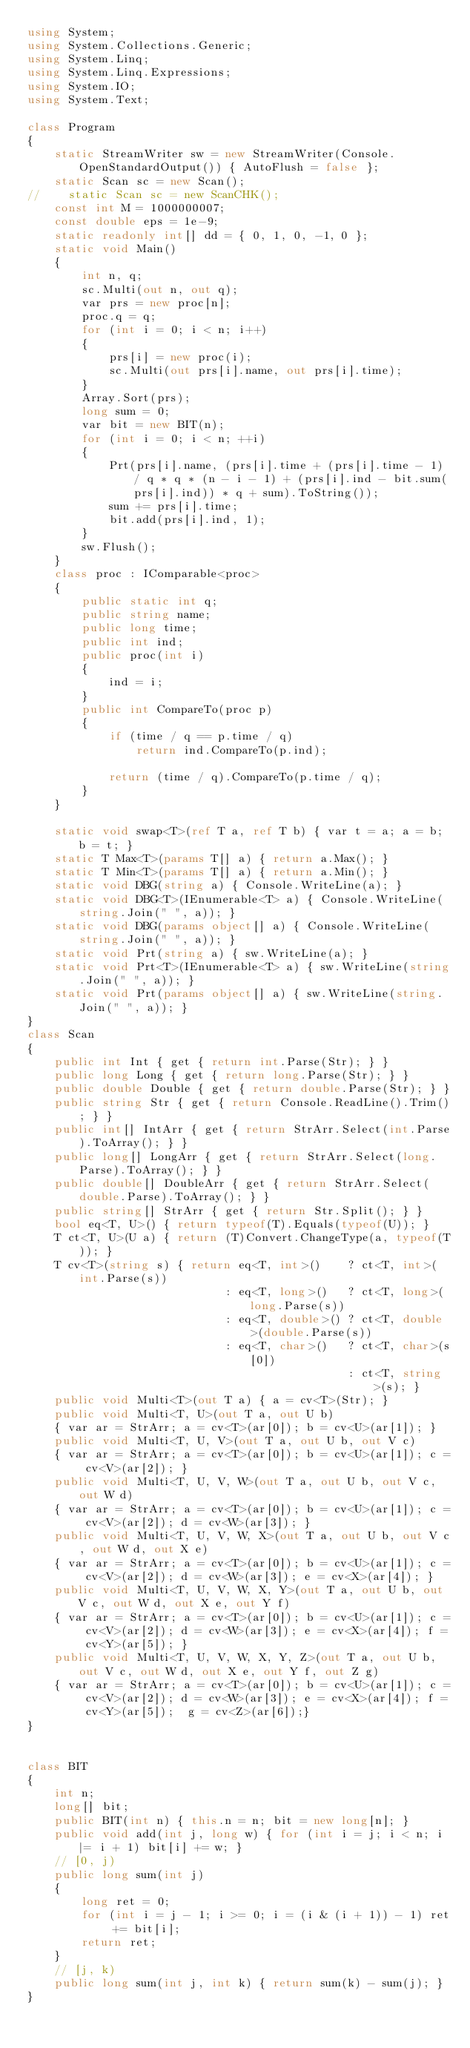Convert code to text. <code><loc_0><loc_0><loc_500><loc_500><_C#_>using System;
using System.Collections.Generic;
using System.Linq;
using System.Linq.Expressions;
using System.IO;
using System.Text;

class Program
{
    static StreamWriter sw = new StreamWriter(Console.OpenStandardOutput()) { AutoFlush = false };
    static Scan sc = new Scan();
//    static Scan sc = new ScanCHK();
    const int M = 1000000007;
    const double eps = 1e-9;
    static readonly int[] dd = { 0, 1, 0, -1, 0 };
    static void Main()
    {
        int n, q;
        sc.Multi(out n, out q);
        var prs = new proc[n];
        proc.q = q;
        for (int i = 0; i < n; i++)
        {
            prs[i] = new proc(i);
            sc.Multi(out prs[i].name, out prs[i].time);
        }
        Array.Sort(prs);
        long sum = 0;
        var bit = new BIT(n);
        for (int i = 0; i < n; ++i)
        {
            Prt(prs[i].name, (prs[i].time + (prs[i].time - 1) / q * q * (n - i - 1) + (prs[i].ind - bit.sum(prs[i].ind)) * q + sum).ToString());
            sum += prs[i].time;
            bit.add(prs[i].ind, 1);
        }
        sw.Flush();
    }
    class proc : IComparable<proc>
    {
        public static int q;
        public string name;
        public long time;
        public int ind;
        public proc(int i)
        {
            ind = i;
        }
        public int CompareTo(proc p)
        {
            if (time / q == p.time / q)
                return ind.CompareTo(p.ind);

            return (time / q).CompareTo(p.time / q);
        }
    }

    static void swap<T>(ref T a, ref T b) { var t = a; a = b; b = t; }
    static T Max<T>(params T[] a) { return a.Max(); }
    static T Min<T>(params T[] a) { return a.Min(); }
    static void DBG(string a) { Console.WriteLine(a); }
    static void DBG<T>(IEnumerable<T> a) { Console.WriteLine(string.Join(" ", a)); }
    static void DBG(params object[] a) { Console.WriteLine(string.Join(" ", a)); }
    static void Prt(string a) { sw.WriteLine(a); }
    static void Prt<T>(IEnumerable<T> a) { sw.WriteLine(string.Join(" ", a)); }
    static void Prt(params object[] a) { sw.WriteLine(string.Join(" ", a)); }
}
class Scan
{
    public int Int { get { return int.Parse(Str); } }
    public long Long { get { return long.Parse(Str); } }
    public double Double { get { return double.Parse(Str); } }
    public string Str { get { return Console.ReadLine().Trim(); } }
    public int[] IntArr { get { return StrArr.Select(int.Parse).ToArray(); } }
    public long[] LongArr { get { return StrArr.Select(long.Parse).ToArray(); } }
    public double[] DoubleArr { get { return StrArr.Select(double.Parse).ToArray(); } }
    public string[] StrArr { get { return Str.Split(); } }
    bool eq<T, U>() { return typeof(T).Equals(typeof(U)); }
    T ct<T, U>(U a) { return (T)Convert.ChangeType(a, typeof(T)); }
    T cv<T>(string s) { return eq<T, int>()    ? ct<T, int>(int.Parse(s))
                             : eq<T, long>()   ? ct<T, long>(long.Parse(s))
                             : eq<T, double>() ? ct<T, double>(double.Parse(s))
                             : eq<T, char>()   ? ct<T, char>(s[0])
                                               : ct<T, string>(s); }
    public void Multi<T>(out T a) { a = cv<T>(Str); }
    public void Multi<T, U>(out T a, out U b)
    { var ar = StrArr; a = cv<T>(ar[0]); b = cv<U>(ar[1]); }
    public void Multi<T, U, V>(out T a, out U b, out V c)
    { var ar = StrArr; a = cv<T>(ar[0]); b = cv<U>(ar[1]); c = cv<V>(ar[2]); }
    public void Multi<T, U, V, W>(out T a, out U b, out V c, out W d)
    { var ar = StrArr; a = cv<T>(ar[0]); b = cv<U>(ar[1]); c = cv<V>(ar[2]); d = cv<W>(ar[3]); }
    public void Multi<T, U, V, W, X>(out T a, out U b, out V c, out W d, out X e)
    { var ar = StrArr; a = cv<T>(ar[0]); b = cv<U>(ar[1]); c = cv<V>(ar[2]); d = cv<W>(ar[3]); e = cv<X>(ar[4]); }
    public void Multi<T, U, V, W, X, Y>(out T a, out U b, out V c, out W d, out X e, out Y f)
    { var ar = StrArr; a = cv<T>(ar[0]); b = cv<U>(ar[1]); c = cv<V>(ar[2]); d = cv<W>(ar[3]); e = cv<X>(ar[4]); f = cv<Y>(ar[5]); }
    public void Multi<T, U, V, W, X, Y, Z>(out T a, out U b, out V c, out W d, out X e, out Y f, out Z g)
    { var ar = StrArr; a = cv<T>(ar[0]); b = cv<U>(ar[1]); c = cv<V>(ar[2]); d = cv<W>(ar[3]); e = cv<X>(ar[4]); f = cv<Y>(ar[5]);  g = cv<Z>(ar[6]);}
}


class BIT
{
    int n;
    long[] bit;
    public BIT(int n) { this.n = n; bit = new long[n]; }
    public void add(int j, long w) { for (int i = j; i < n; i |= i + 1) bit[i] += w; }
    // [0, j)
    public long sum(int j)
    {
        long ret = 0;
        for (int i = j - 1; i >= 0; i = (i & (i + 1)) - 1) ret += bit[i];
        return ret;
    }
    // [j, k)
    public long sum(int j, int k) { return sum(k) - sum(j); }
}</code> 